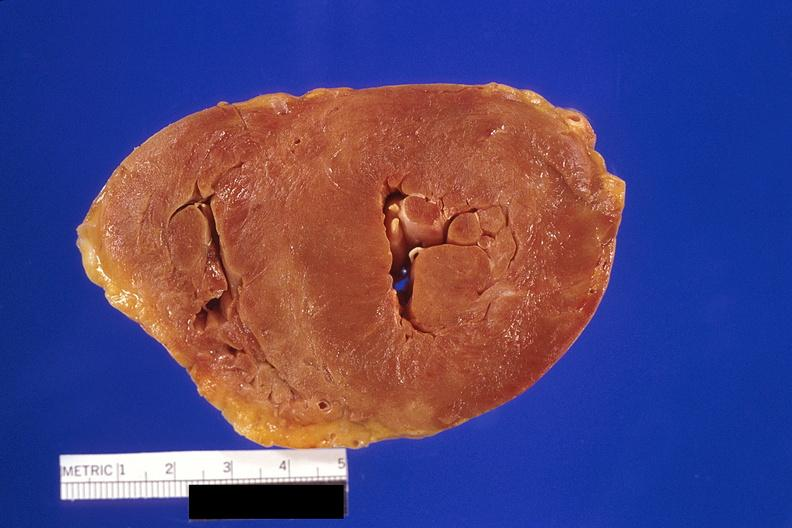what is amyloidosis left?
Answer the question using a single word or phrase. Ventricular hypertrophy 